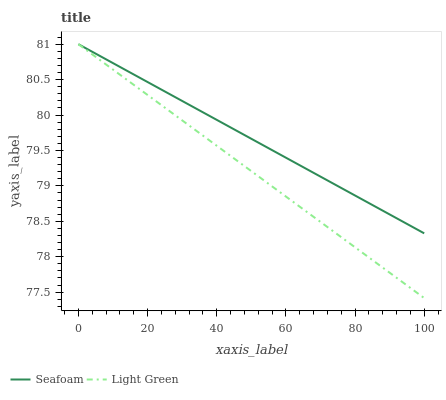Does Light Green have the minimum area under the curve?
Answer yes or no. Yes. Does Seafoam have the maximum area under the curve?
Answer yes or no. Yes. Does Light Green have the maximum area under the curve?
Answer yes or no. No. Is Light Green the smoothest?
Answer yes or no. Yes. Is Seafoam the roughest?
Answer yes or no. Yes. Is Light Green the roughest?
Answer yes or no. No. Does Light Green have the highest value?
Answer yes or no. Yes. 